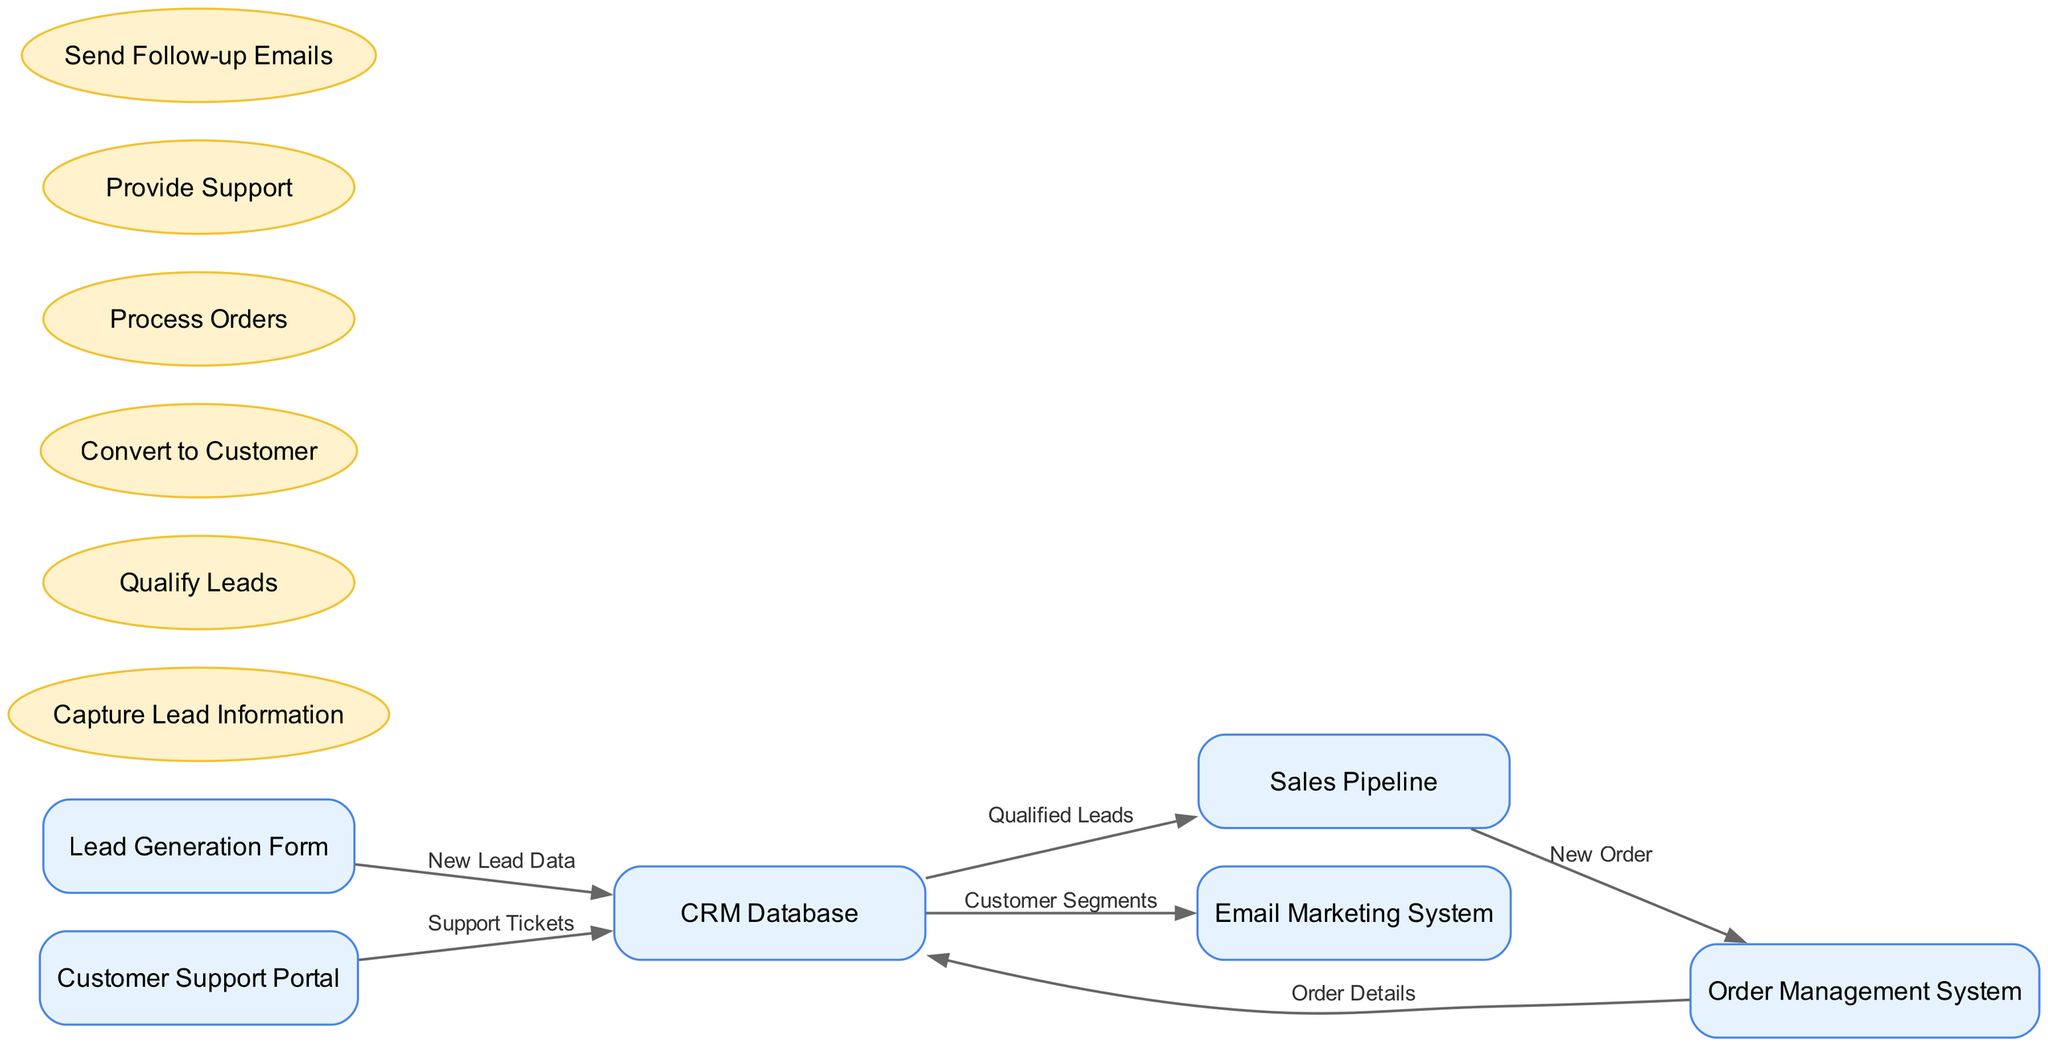What is the starting point of the data flow? The starting point of the data flow in the diagram is "Lead Generation Form," which initiates the process by capturing new lead data that flows into the CRM Database.
Answer: Lead Generation Form How many entities are shown in the diagram? The diagram contains six entities, including the Lead Generation Form, CRM Database, Sales Pipeline, Customer Support Portal, Email Marketing System, and Order Management System.
Answer: 6 What label is used for the data flow from the Sales Pipeline to the Order Management System? The data flow from the Sales Pipeline to the Order Management System is labeled "New Order," indicating that this flow represents the transition of new order information within the process.
Answer: New Order Which process receives data from the CRM Database? The processes receiving data from the CRM Database include "Qualify Leads," "Convert to Customer," and "Send Follow-up Emails." They utilize the qualified lead and customer segment data derived from the CRM Database.
Answer: Qualify Leads, Convert to Customer, Send Follow-up Emails What type of data flows from the Customer Support Portal to the CRM Database? The type of data flowing from the Customer Support Portal to the CRM Database is labeled "Support Tickets," which refers to the tickets generated for customer assistance and support interactions.
Answer: Support Tickets How does a qualified lead move through the system to become a customer? A qualified lead moves from the CRM Database to the Sales Pipeline and then is converted into a customer via the process "Convert to Customer," which signifies their transition from a potential to a confirmed customer status.
Answer: Sales Pipeline What data is sent from the Order Management System back to the CRM Database? The data sent from the Order Management System back to the CRM Database is labeled "Order Details," which provide essential information about the customer's order after it has been processed.
Answer: Order Details What system receives customer segments from the CRM Database? The system that receives customer segments from the CRM Database is the "Email Marketing System," which likely uses the segments for targeted marketing campaigns aimed at specific customer groups.
Answer: Email Marketing System 